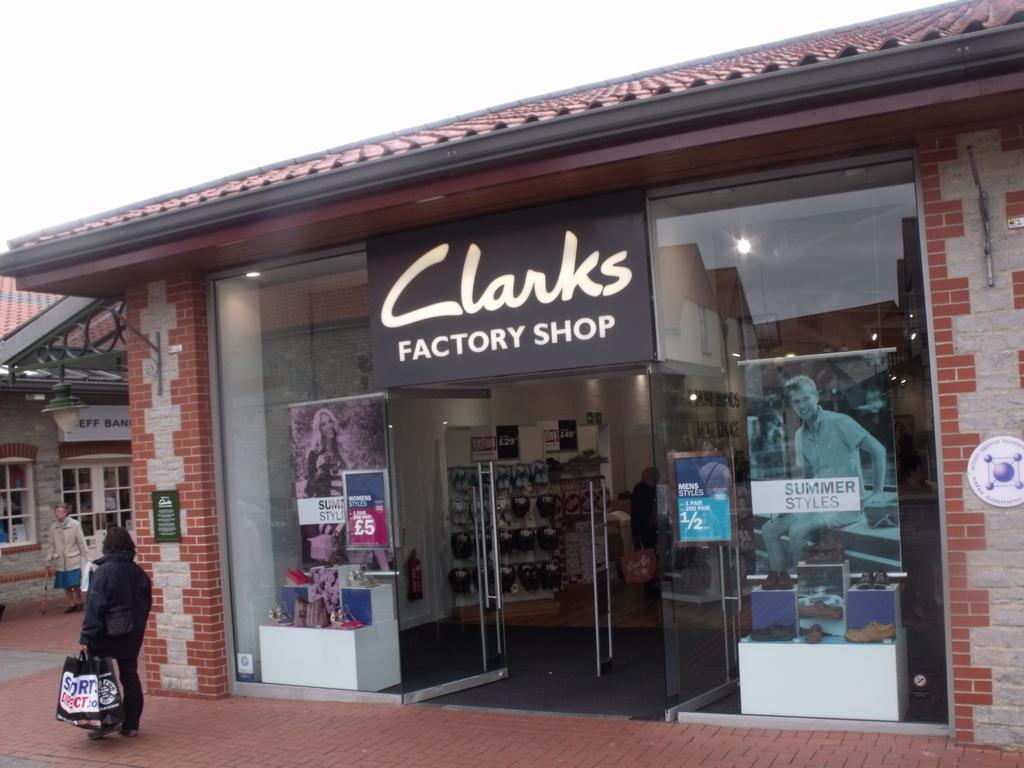Please provide a concise description of this image. In this image in the center there is one store, in that store there are some caps and some boxes and some persons and also there is one glass door. On the door there are some posters, on the left side there two persons who are walking and also there are some buildings. At the bottom there is a walkway. 